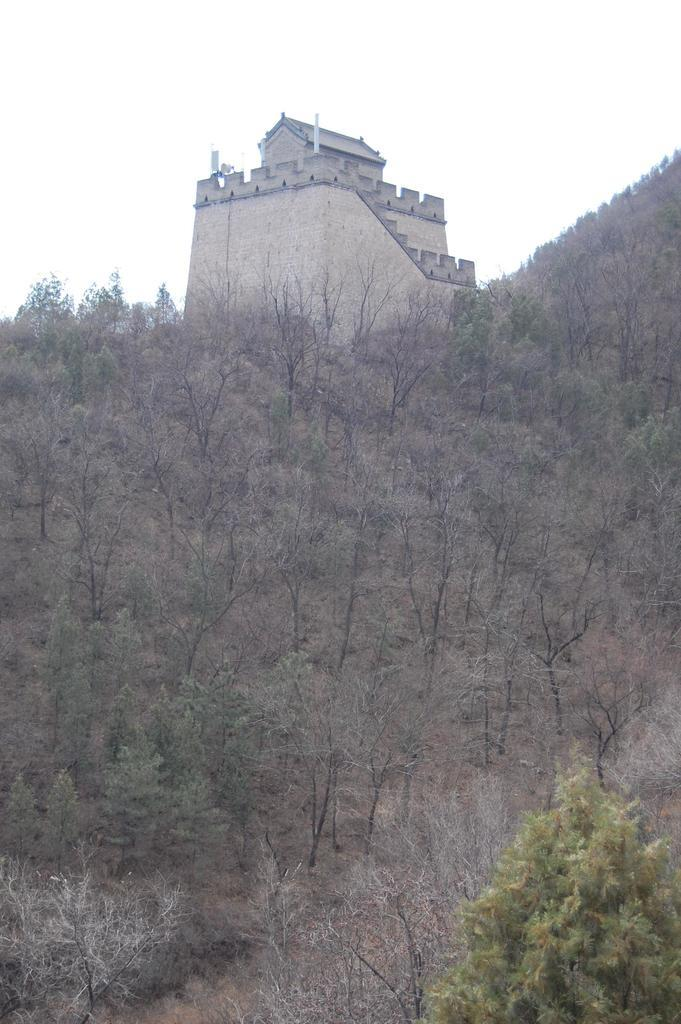What type of vegetation can be seen in the image? There are trees in the image. What type of structure is present in the image? There is a building in the image. What can be seen in the background of the image? The sky is visible in the background of the image. What type of wine is being served at the picnic in the image? There is no picnic or wine present in the image; it features trees and a building. How many times does the earth rotate in the image? The image does not depict the earth rotating; it shows trees, a building, and the sky. 